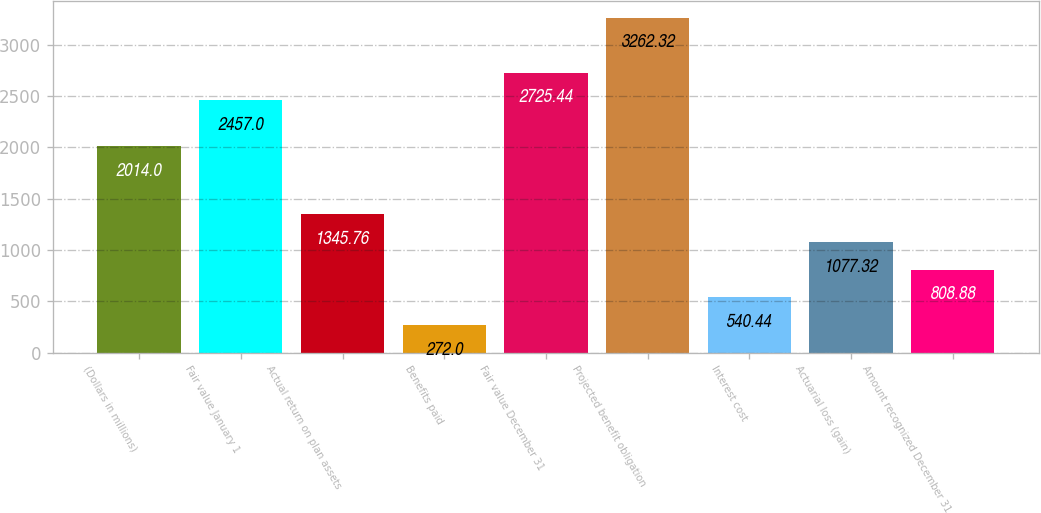Convert chart to OTSL. <chart><loc_0><loc_0><loc_500><loc_500><bar_chart><fcel>(Dollars in millions)<fcel>Fair value January 1<fcel>Actual return on plan assets<fcel>Benefits paid<fcel>Fair value December 31<fcel>Projected benefit obligation<fcel>Interest cost<fcel>Actuarial loss (gain)<fcel>Amount recognized December 31<nl><fcel>2014<fcel>2457<fcel>1345.76<fcel>272<fcel>2725.44<fcel>3262.32<fcel>540.44<fcel>1077.32<fcel>808.88<nl></chart> 